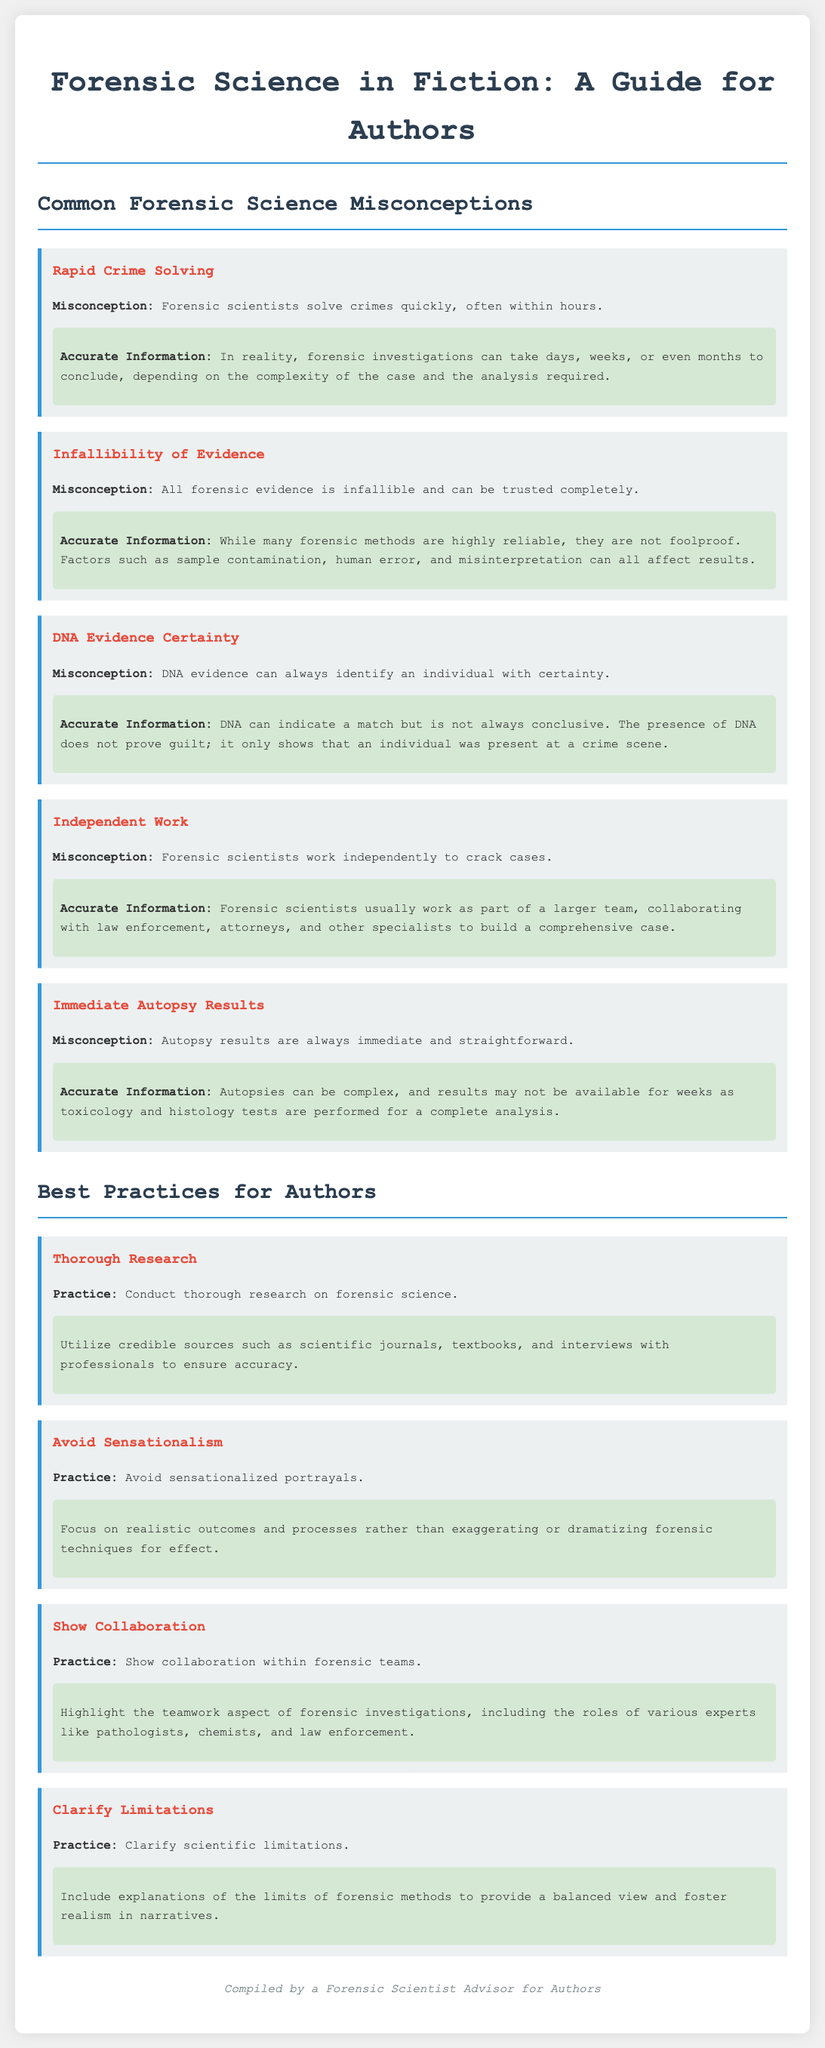What is the title of the document? The title refers to the main heading of the document which provides insight into its content related to forensic science.
Answer: Forensic Science in Fiction: A Guide for Authors How many common forensic science misconceptions are listed? The document enumerates and describes multiple misconceptions regarding forensic science.
Answer: Five What is one misconception about autopsy results? This misconception specifically addresses the timing and clarity of findings from autopsies.
Answer: Immediate and straightforward What is an example of a best practice for authors? This practice encourages thorough research to ensure the accuracy of forensic details in fiction.
Answer: Thorough research What does the document suggest about forensic evidence? This highlights an important aspect regarding the reliability and trustworthiness of forensic methods.
Answer: Not infallible What does the document advise against in forensic portrayals? This advice pertains to the manner in which forensic techniques are depicted in fiction.
Answer: Sensationalism Who compiled the document? This information indicates the author or creator of the guide, lending credibility to the insights provided.
Answer: A Forensic Scientist Advisor for Authors What should authors clarify regarding forensic science? This recommendation focuses on an element of realism that authors should incorporate into their narratives.
Answer: Scientific limitations 